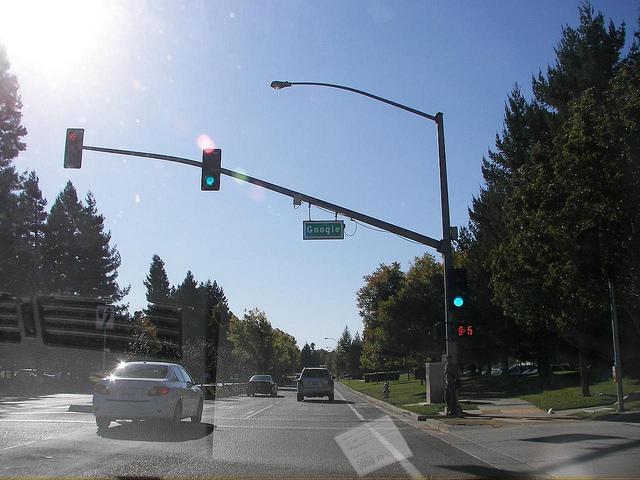What color is the light?
Quick response, please. Green. What does the green sign say?
Quick response, please. Google. Is this a country road?
Concise answer only. No. Is it hazy?
Answer briefly. No. What time was this taken?
Write a very short answer. Afternoon. Is the traffic signal red?
Answer briefly. No. 